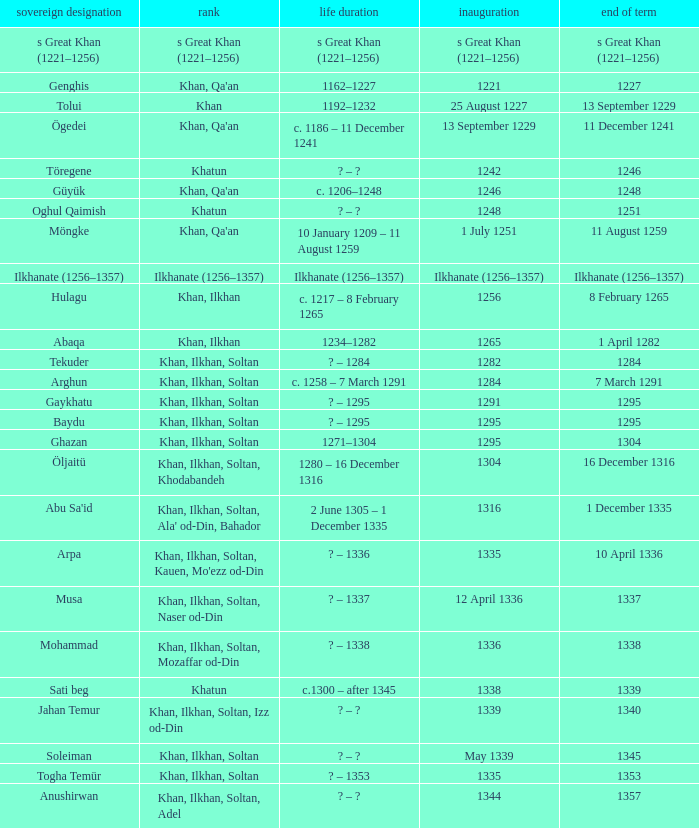What is the entered office that has 1337 as the left office? 12 April 1336. 